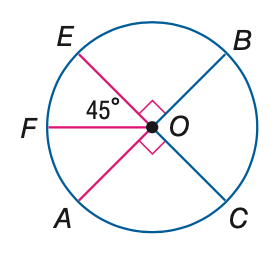Answer the mathemtical geometry problem and directly provide the correct option letter.
Question: E C and A B are diameters of \odot O. Find its measure of \widehat A C E.
Choices: A: 60 B: 90 C: 180 D: 270 D 